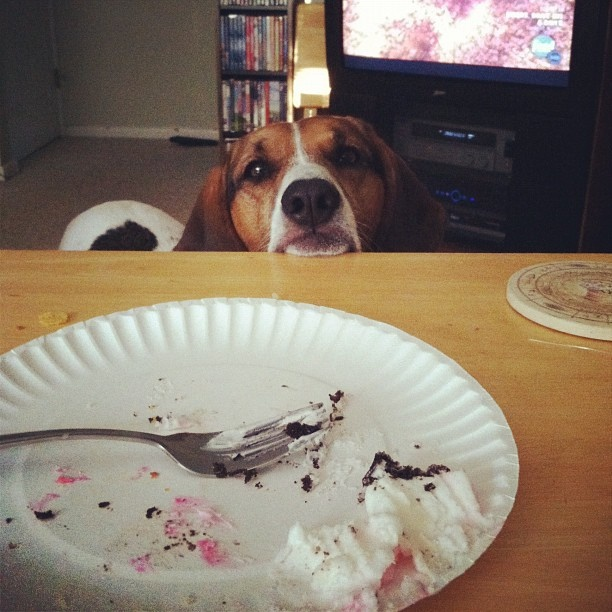Describe the objects in this image and their specific colors. I can see dining table in black, darkgray, tan, lightgray, and brown tones, dog in black, maroon, and brown tones, tv in black, white, navy, and pink tones, cake in black, darkgray, lightgray, and tan tones, and fork in black, gray, and darkgray tones in this image. 